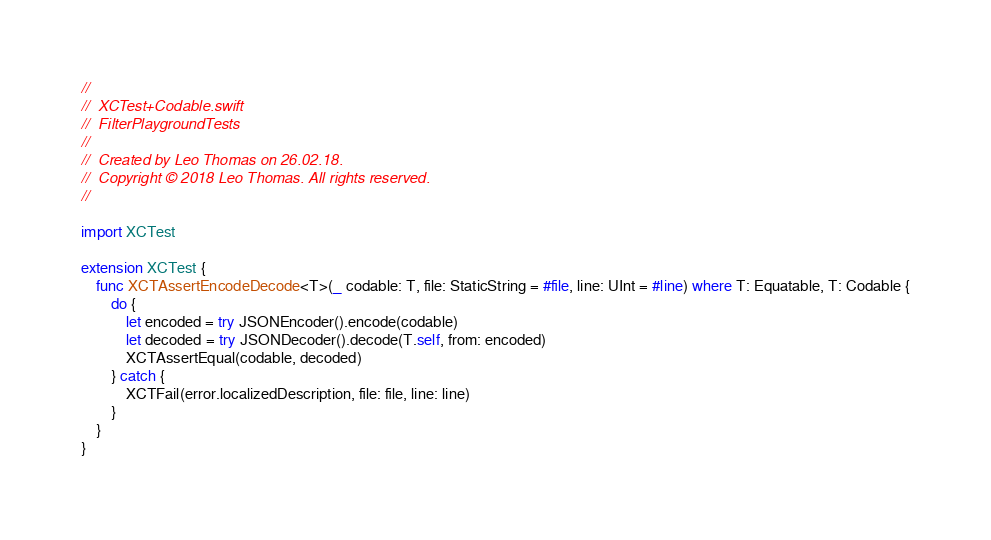Convert code to text. <code><loc_0><loc_0><loc_500><loc_500><_Swift_>//
//  XCTest+Codable.swift
//  FilterPlaygroundTests
//
//  Created by Leo Thomas on 26.02.18.
//  Copyright © 2018 Leo Thomas. All rights reserved.
//

import XCTest

extension XCTest {
    func XCTAssertEncodeDecode<T>(_ codable: T, file: StaticString = #file, line: UInt = #line) where T: Equatable, T: Codable {
        do {
            let encoded = try JSONEncoder().encode(codable)
            let decoded = try JSONDecoder().decode(T.self, from: encoded)
            XCTAssertEqual(codable, decoded)
        } catch {
            XCTFail(error.localizedDescription, file: file, line: line)
        }
    }
}
</code> 